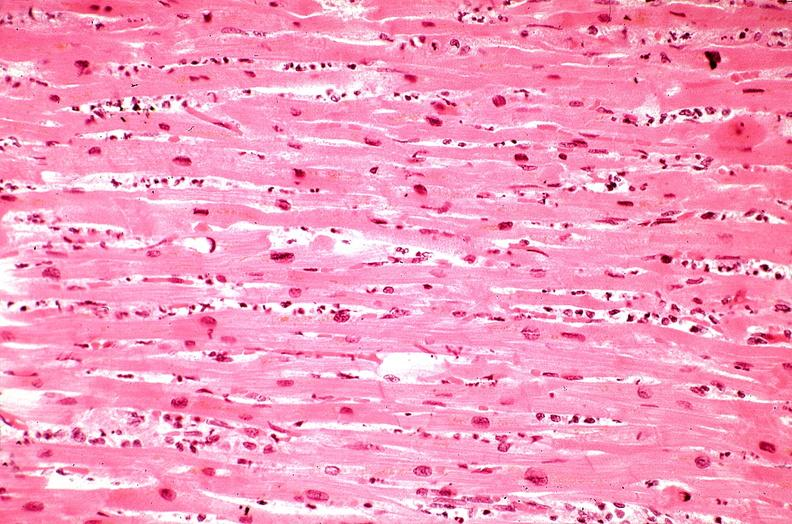does polycystic disease show heart, myocardial infarction, wavey fiber change, necrtosis, hemorrhage, and dissection?
Answer the question using a single word or phrase. No 